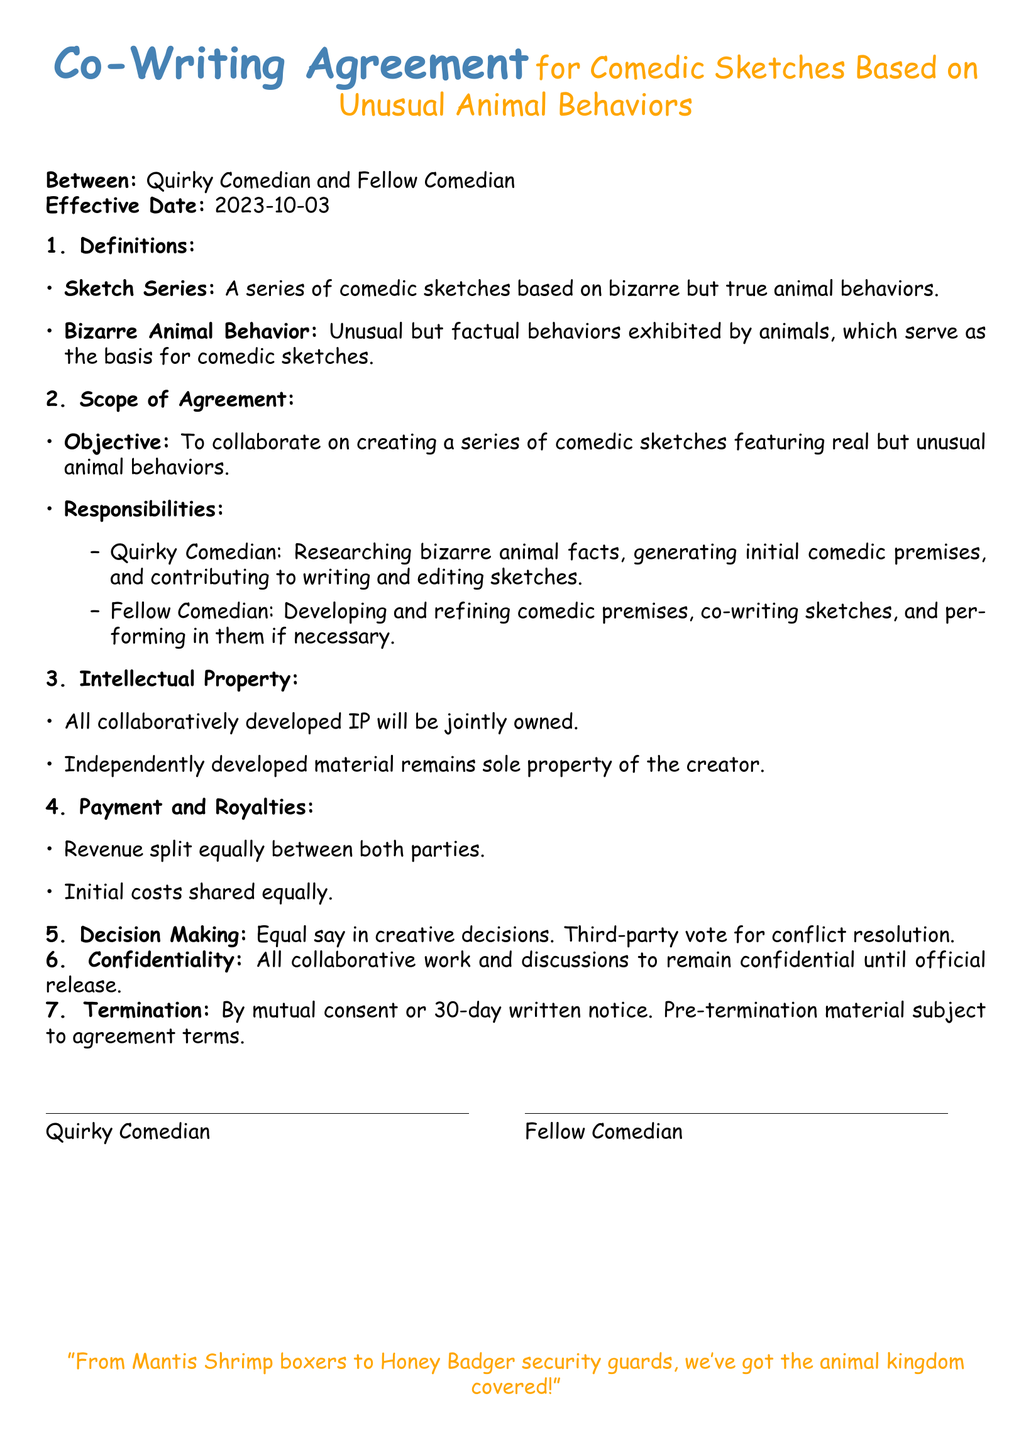What is the effective date of the agreement? The effective date of the agreement is specified in the document under the "Effective Date" section.
Answer: 2023-10-03 What is the objective of the agreement? The objective is outlined in the "Scope of Agreement" section, indicating the purpose of the collaboration.
Answer: Create a series of comedic sketches featuring real but unusual animal behaviors Who is responsible for researching bizarre animal facts? The responsibilities are outlined in the "Responsibilities" subsection, detailing each party's tasks.
Answer: Quirky Comedian How will revenue be split between the parties? The revenue split is mentioned under the "Payment and Royalties" section, clarifying the financial arrangement between the comedians.
Answer: Equally What type of vote is required for conflict resolution? The "Decision Making" section specifies the method to resolve conflicts, detailing the type of vote needed.
Answer: Third-party vote What happens if one party wants to terminate the agreement? The "Termination" section provides guidance on how to proceed with terminating the contract.
Answer: 30-day written notice What colors are used for the document title? The colors used in the title are indicated by the color definitions in the document preamble.
Answer: Quirky blue and quirky orange Who owns the collaboratively developed intellectual property? The ownership of intellectual property is addressed in the "Intellectual Property" section, clarifying ownership rights.
Answer: Jointly owned 